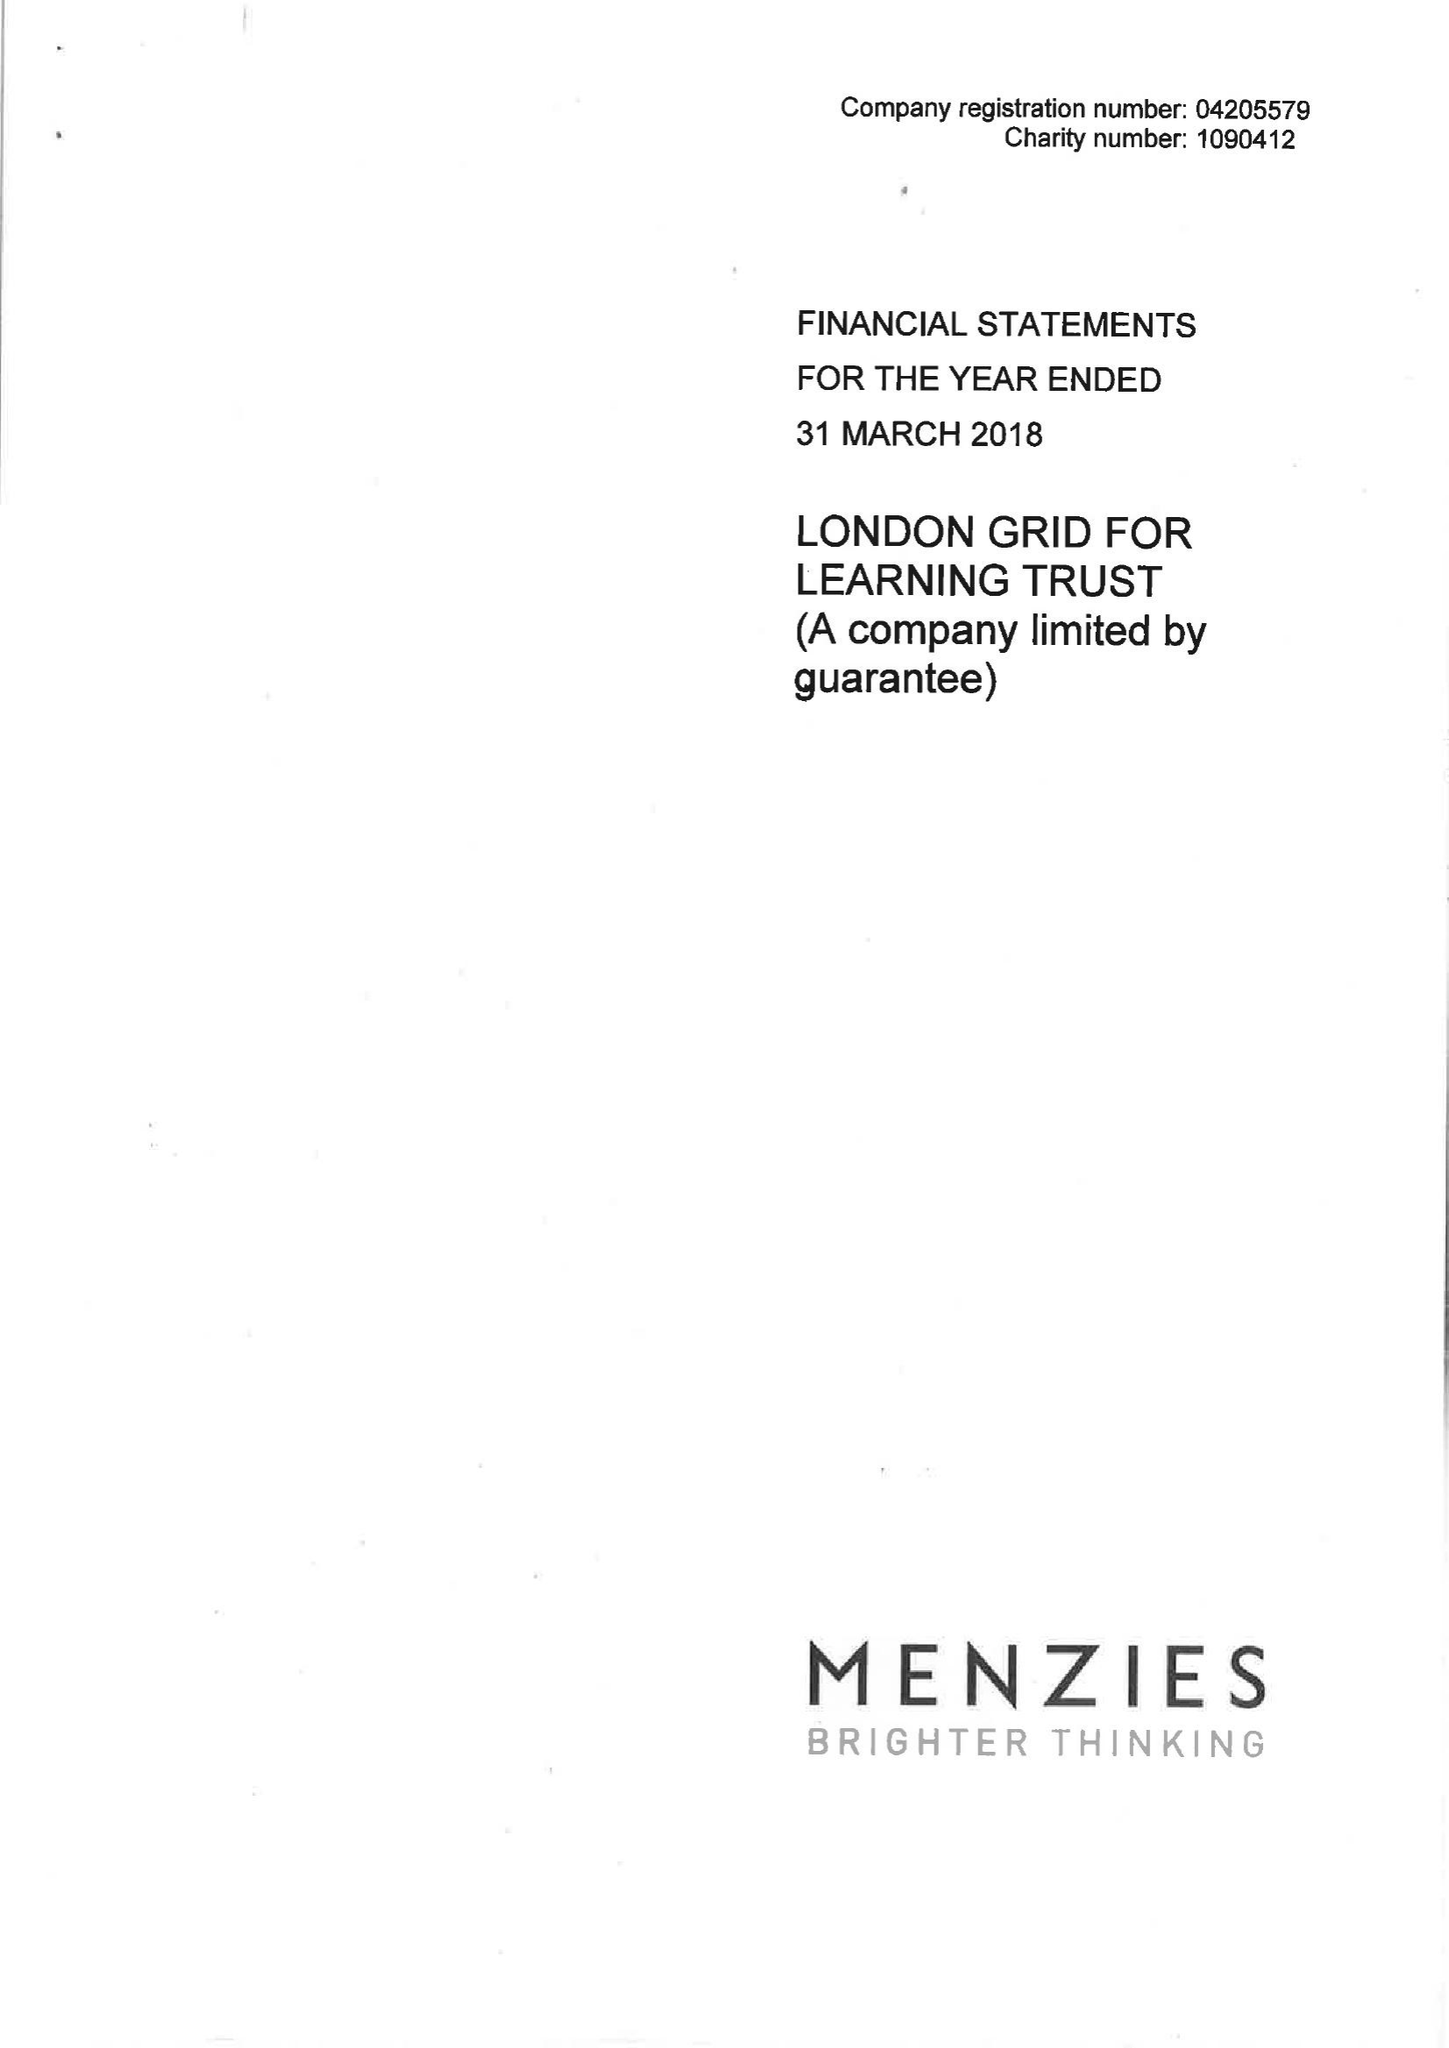What is the value for the address__street_line?
Answer the question using a single word or phrase. PRIMROSE STREET 